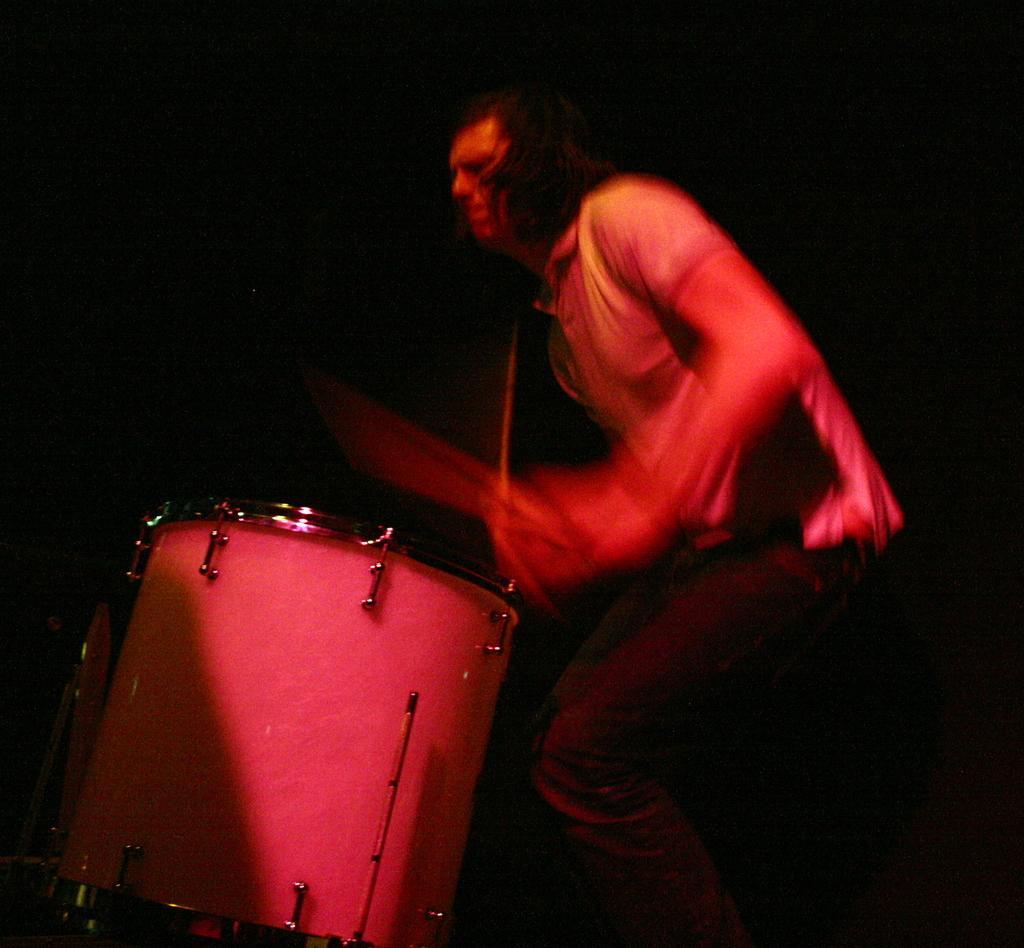Please provide a concise description of this image. In this image there is a person playing musical instrument and lighting on the person. 